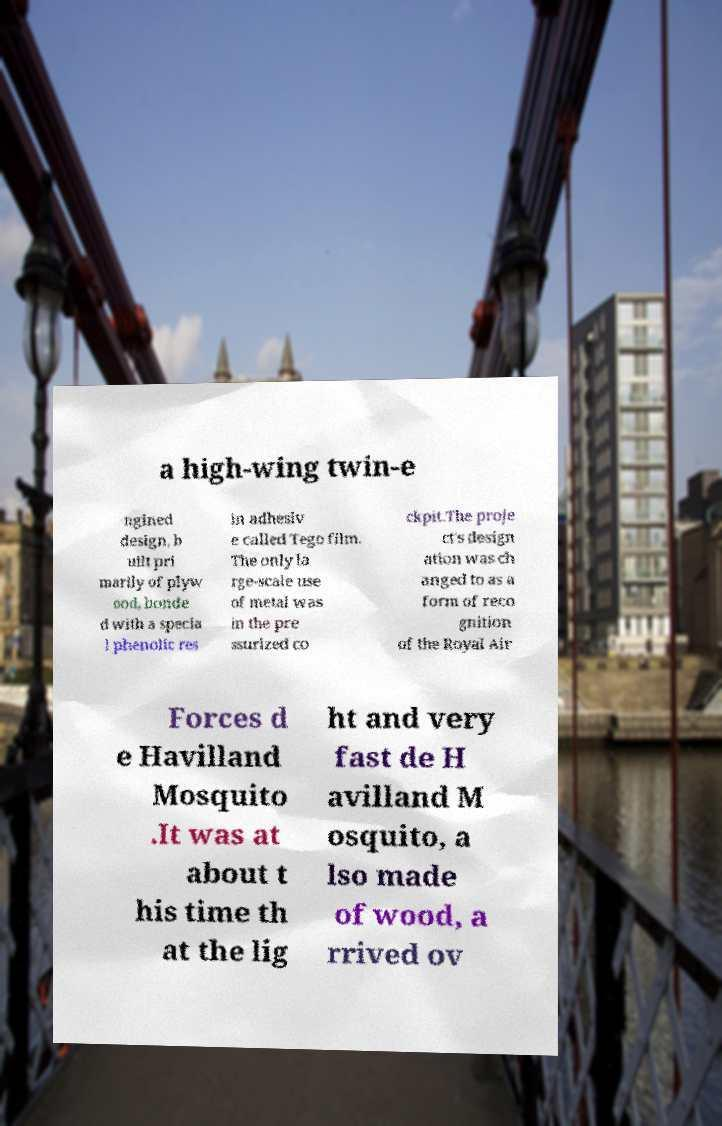Can you accurately transcribe the text from the provided image for me? a high-wing twin-e ngined design, b uilt pri marily of plyw ood, bonde d with a specia l phenolic res in adhesiv e called Tego film. The only la rge-scale use of metal was in the pre ssurized co ckpit.The proje ct's design ation was ch anged to as a form of reco gnition of the Royal Air Forces d e Havilland Mosquito .It was at about t his time th at the lig ht and very fast de H avilland M osquito, a lso made of wood, a rrived ov 